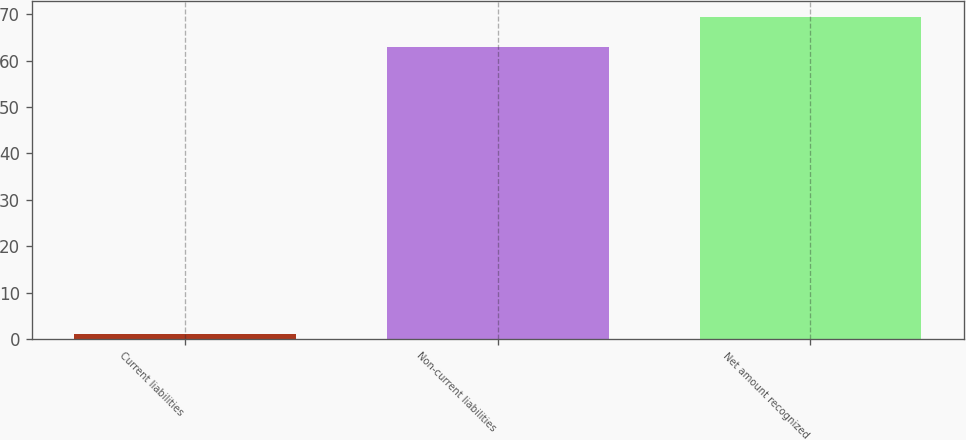<chart> <loc_0><loc_0><loc_500><loc_500><bar_chart><fcel>Current liabilities<fcel>Non-current liabilities<fcel>Net amount recognized<nl><fcel>1<fcel>63<fcel>69.3<nl></chart> 